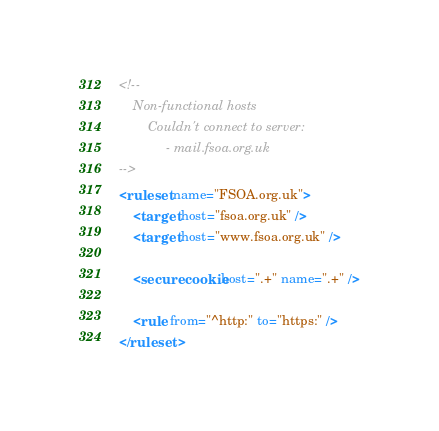<code> <loc_0><loc_0><loc_500><loc_500><_XML_><!--
	Non-functional hosts
		Couldn't connect to server:
			 - mail.fsoa.org.uk
-->
<ruleset name="FSOA.org.uk">
	<target host="fsoa.org.uk" />
	<target host="www.fsoa.org.uk" />

	<securecookie host=".+" name=".+" />

	<rule from="^http:" to="https:" />
</ruleset>
</code> 